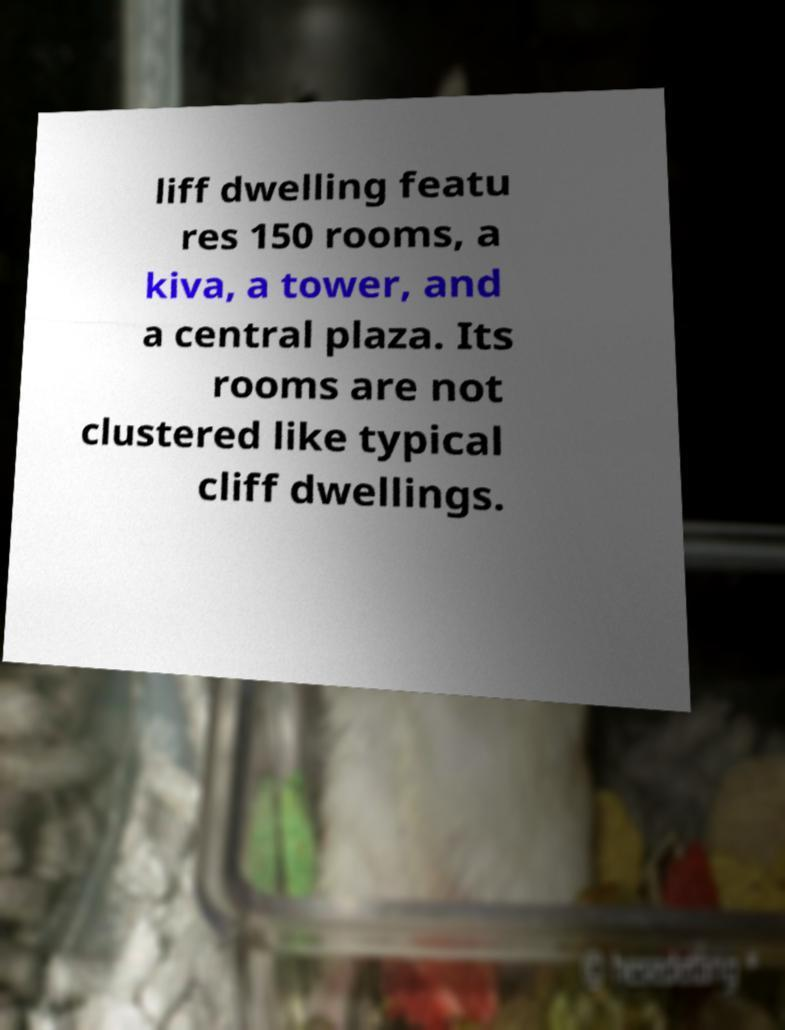Could you extract and type out the text from this image? liff dwelling featu res 150 rooms, a kiva, a tower, and a central plaza. Its rooms are not clustered like typical cliff dwellings. 